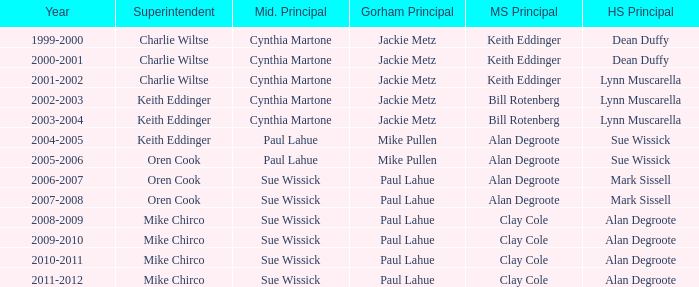Who was the gorham principal in 2010-2011? Paul Lahue. 